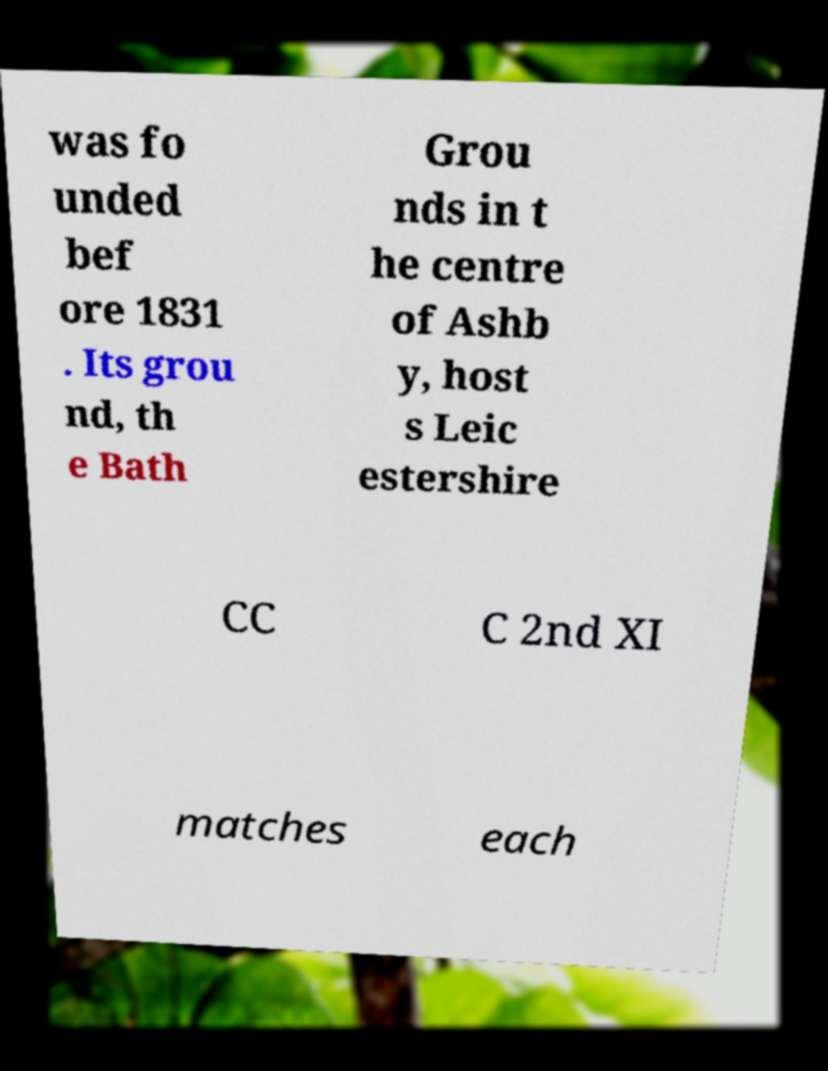Can you read and provide the text displayed in the image?This photo seems to have some interesting text. Can you extract and type it out for me? was fo unded bef ore 1831 . Its grou nd, th e Bath Grou nds in t he centre of Ashb y, host s Leic estershire CC C 2nd XI matches each 